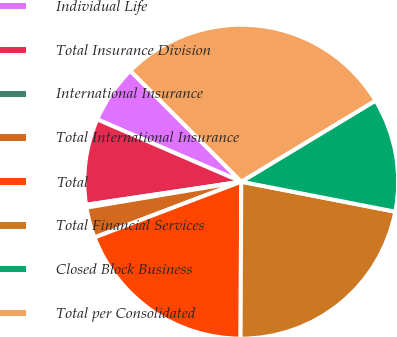Convert chart. <chart><loc_0><loc_0><loc_500><loc_500><pie_chart><fcel>Individual Life<fcel>Total Insurance Division<fcel>International Insurance<fcel>Total International Insurance<fcel>Total<fcel>Total Financial Services<fcel>Closed Block Business<fcel>Total per Consolidated<nl><fcel>6.0%<fcel>8.85%<fcel>0.29%<fcel>3.14%<fcel>19.15%<fcel>22.01%<fcel>11.71%<fcel>28.85%<nl></chart> 